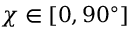<formula> <loc_0><loc_0><loc_500><loc_500>\chi \in [ 0 , 9 0 ^ { \circ } ]</formula> 